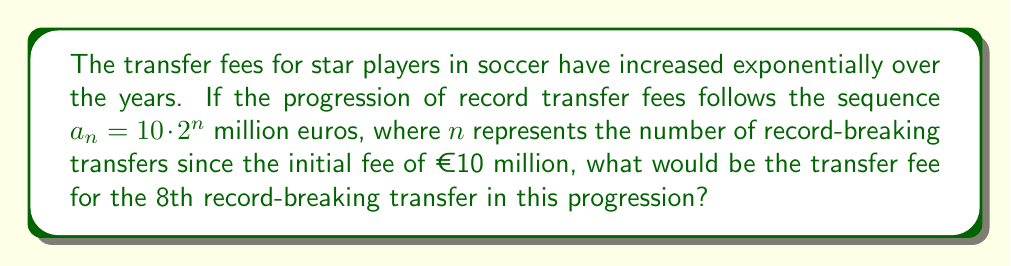Give your solution to this math problem. Let's approach this step-by-step:

1) We're given the sequence $a_n = 10 \cdot 2^n$ million euros, where:
   - $a_n$ is the transfer fee for the nth record-breaking transfer
   - 10 is the initial fee in millions of euros
   - 2 is the common ratio of the geometric progression
   - $n$ is the number of record-breaking transfers since the initial fee

2) We need to find the 8th record-breaking transfer fee, so $n = 8$

3) Let's substitute $n = 8$ into our formula:

   $$a_8 = 10 \cdot 2^8$$

4) Now, let's calculate $2^8$:
   
   $$2^8 = 2 \cdot 2 \cdot 2 \cdot 2 \cdot 2 \cdot 2 \cdot 2 \cdot 2 = 256$$

5) Multiply this by 10:

   $$a_8 = 10 \cdot 256 = 2560$$

Therefore, the 8th record-breaking transfer fee would be 2560 million euros, or €2.56 billion.
Answer: €2.56 billion 